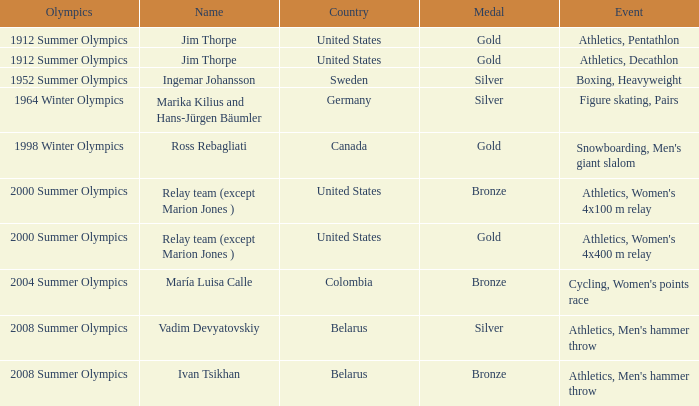What country has a silver medal in the boxing, heavyweight event? Sweden. 